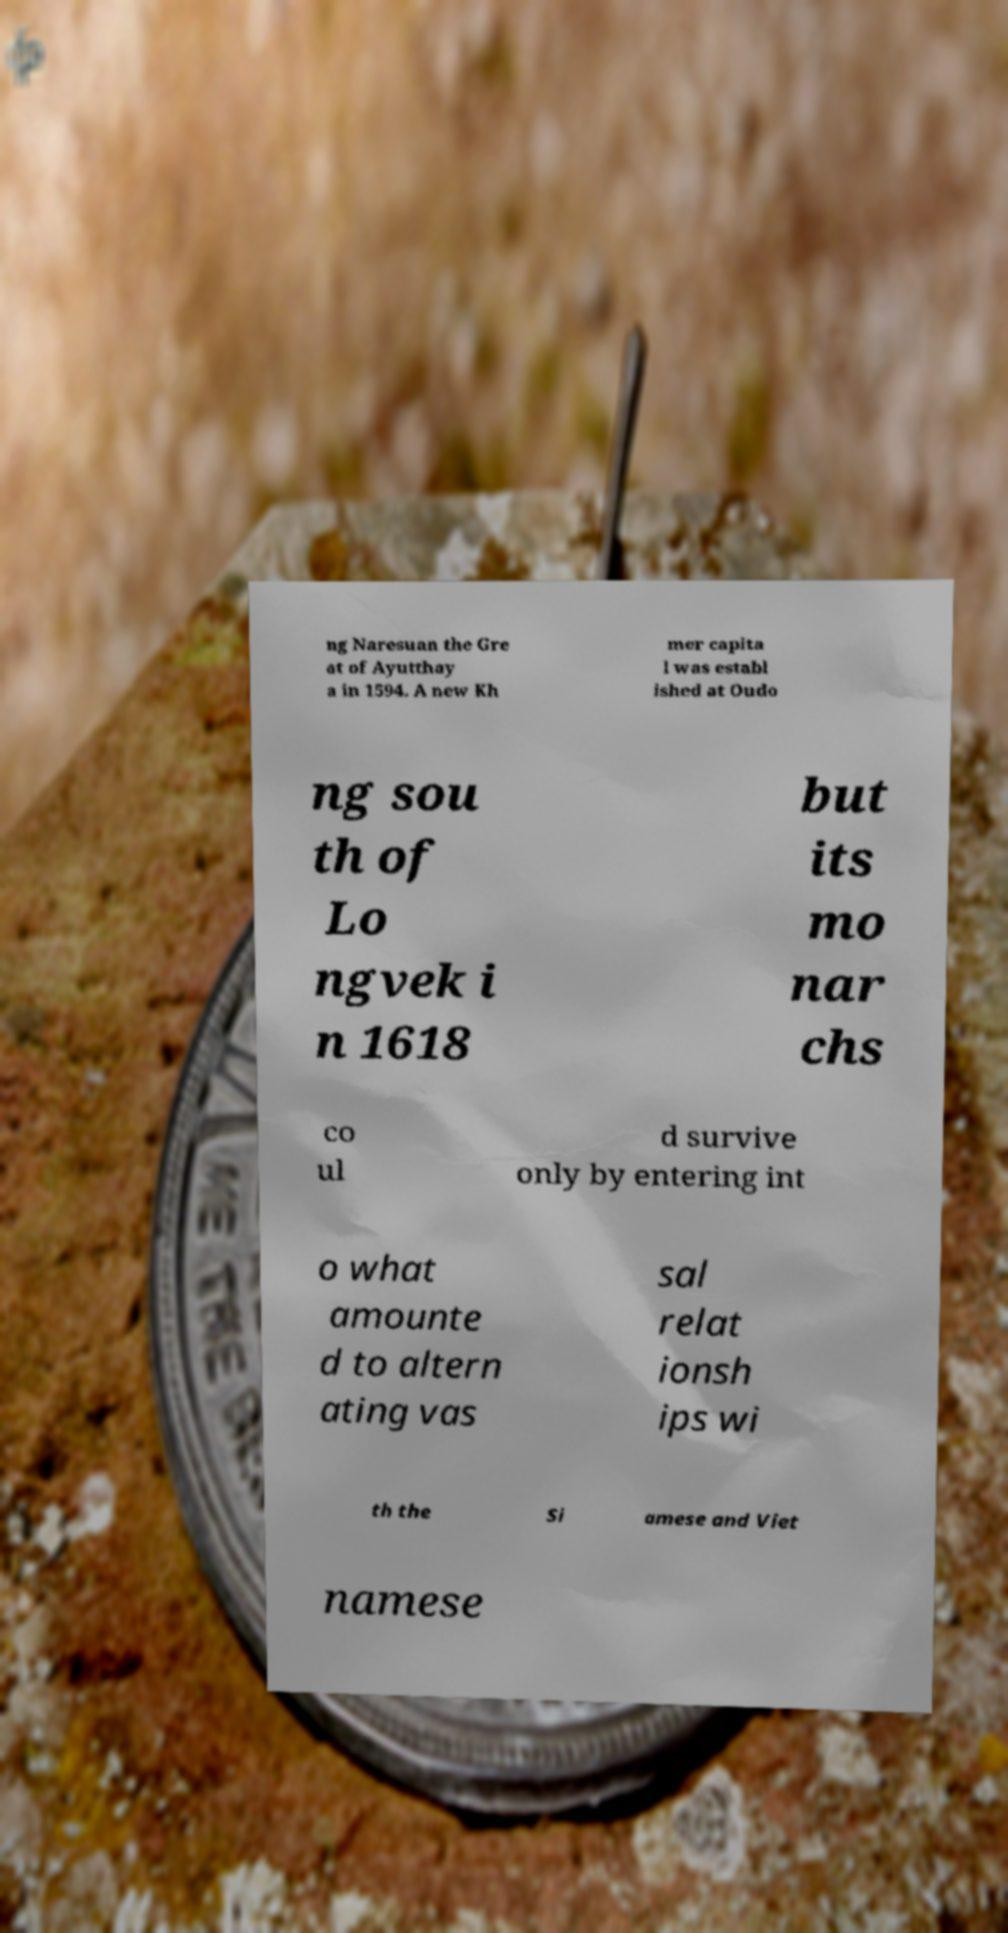Please identify and transcribe the text found in this image. ng Naresuan the Gre at of Ayutthay a in 1594. A new Kh mer capita l was establ ished at Oudo ng sou th of Lo ngvek i n 1618 but its mo nar chs co ul d survive only by entering int o what amounte d to altern ating vas sal relat ionsh ips wi th the Si amese and Viet namese 